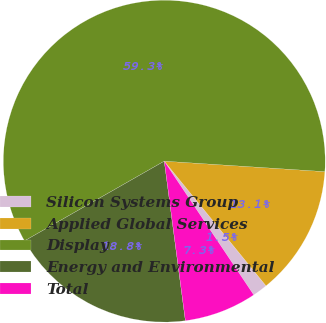Convert chart. <chart><loc_0><loc_0><loc_500><loc_500><pie_chart><fcel>Silicon Systems Group<fcel>Applied Global Services<fcel>Display<fcel>Energy and Environmental<fcel>Total<nl><fcel>1.51%<fcel>13.07%<fcel>59.29%<fcel>18.84%<fcel>7.29%<nl></chart> 